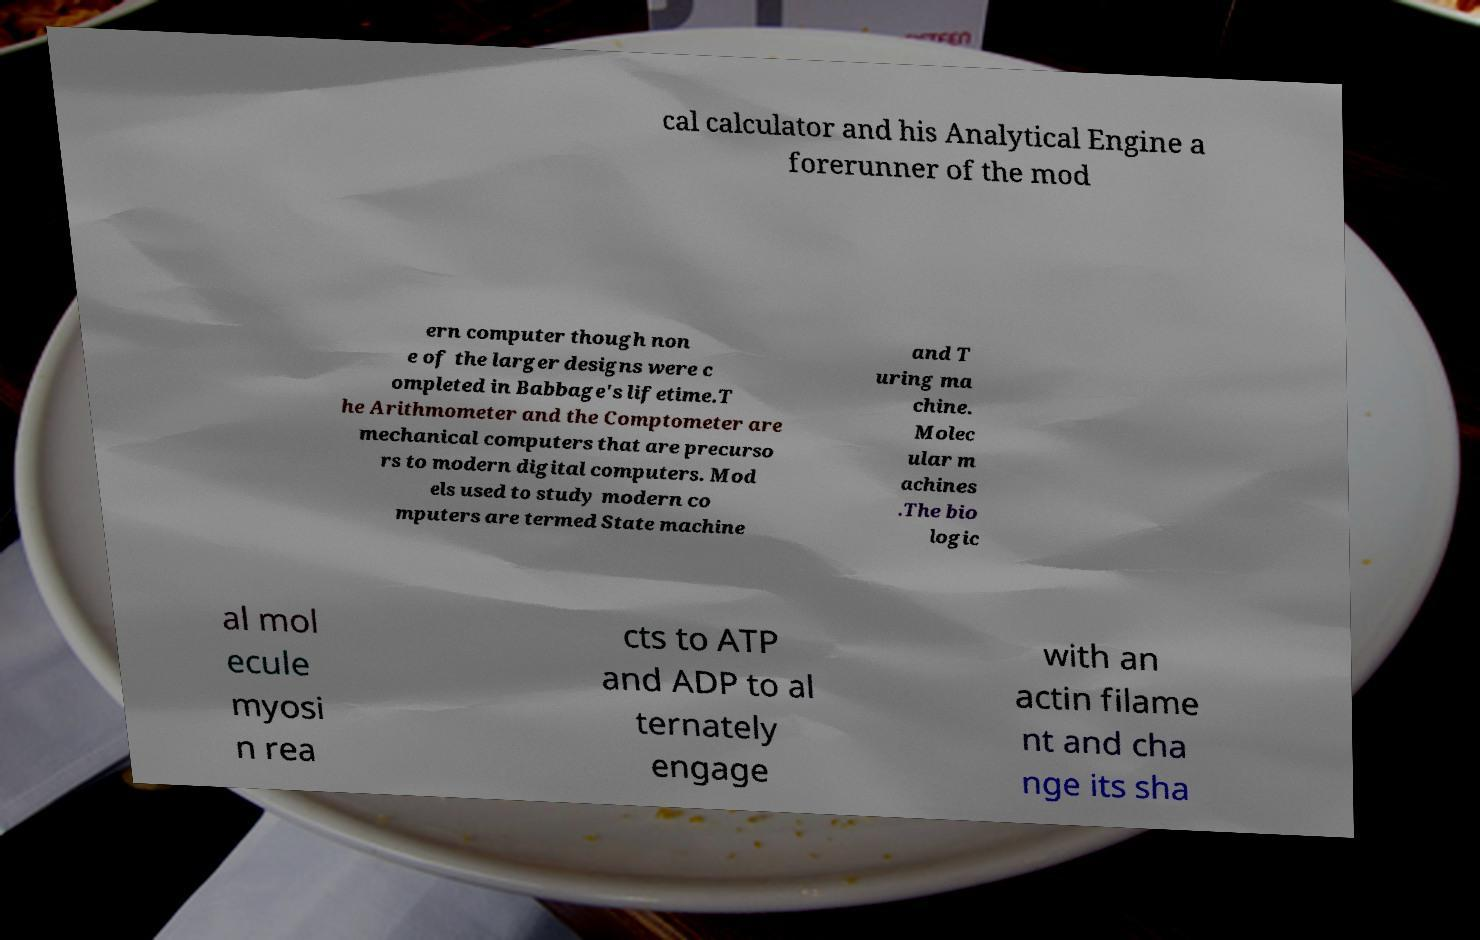Can you accurately transcribe the text from the provided image for me? cal calculator and his Analytical Engine a forerunner of the mod ern computer though non e of the larger designs were c ompleted in Babbage's lifetime.T he Arithmometer and the Comptometer are mechanical computers that are precurso rs to modern digital computers. Mod els used to study modern co mputers are termed State machine and T uring ma chine. Molec ular m achines .The bio logic al mol ecule myosi n rea cts to ATP and ADP to al ternately engage with an actin filame nt and cha nge its sha 